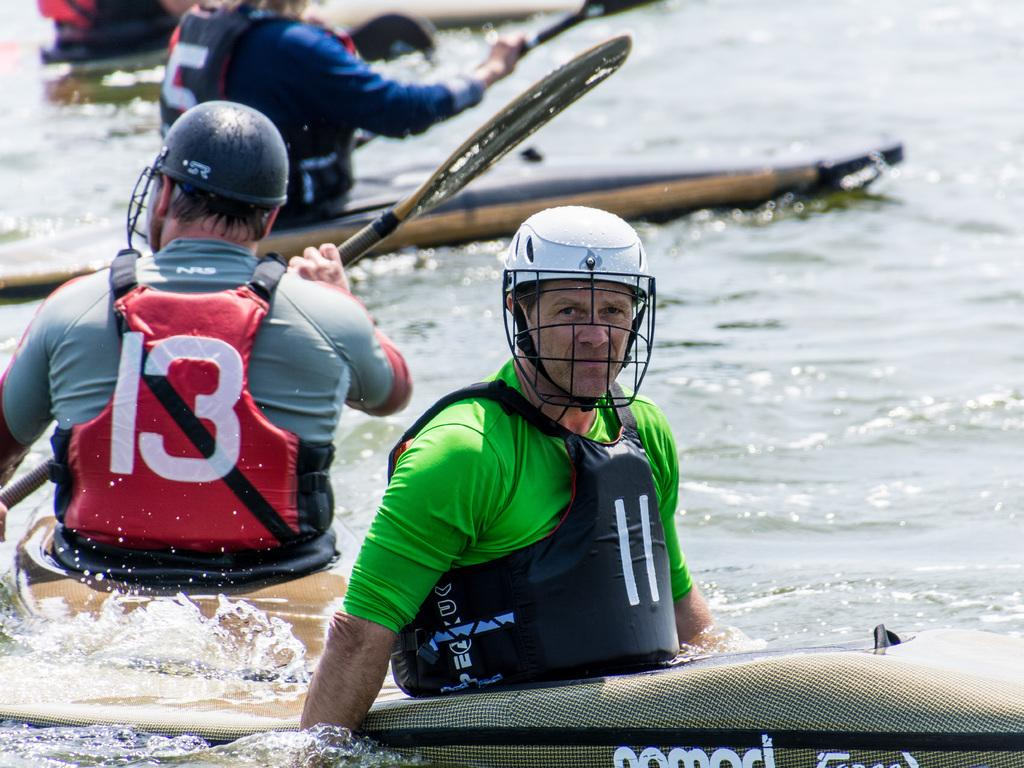Who is in the image? There are people in the image. What are the people doing in the image? The people are on a boat and rowing on the water surface. What safety measures are the people taking in the image? The people are wearing safety jackets and helmets. How many friends can be seen in the image? There is no mention of friends in the image; it only shows people on a boat. What type of drain is visible in the image? There is no drain present in the image; it features people on a boat rowing on the water surface. 